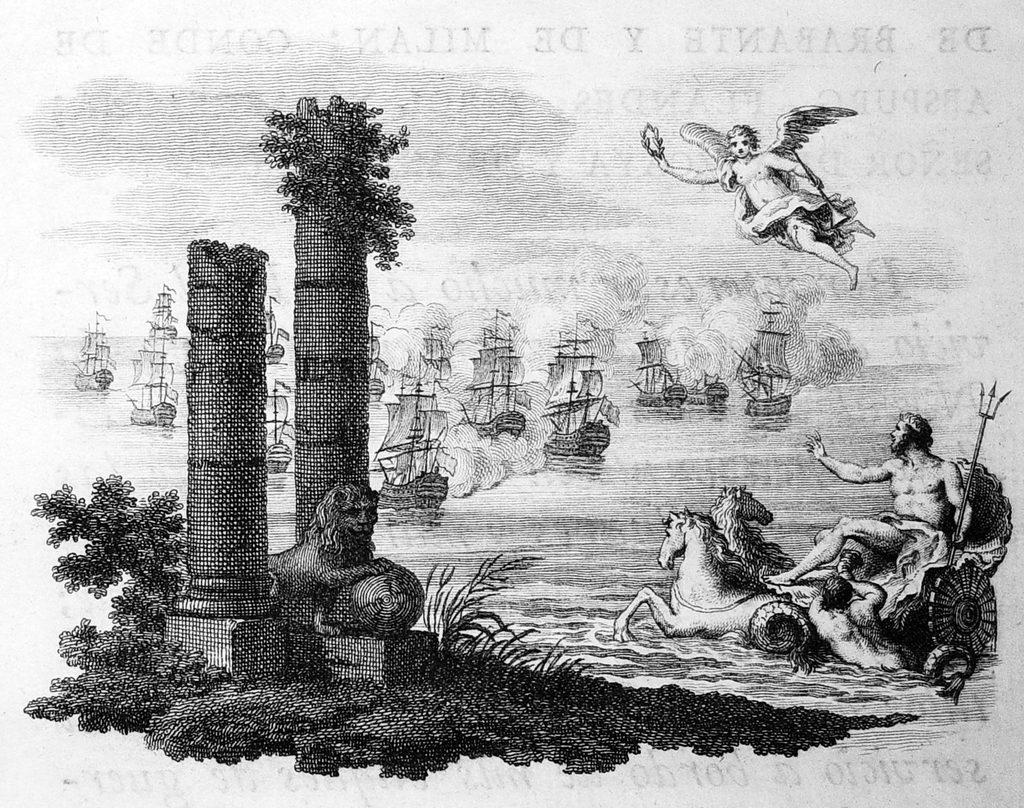What is the main subject of the poster in the image? The poster contains images of people, animals, plants, and boats. What other elements are present on the poster besides the images? The poster contains text. What type of border is depicted around the images on the poster? There is no mention of a border around the images on the poster in the provided facts. How does the poster convey a sense of harmony among the different elements? The provided facts do not discuss the poster's design or composition, so we cannot determine how it conveys a sense of harmony. 